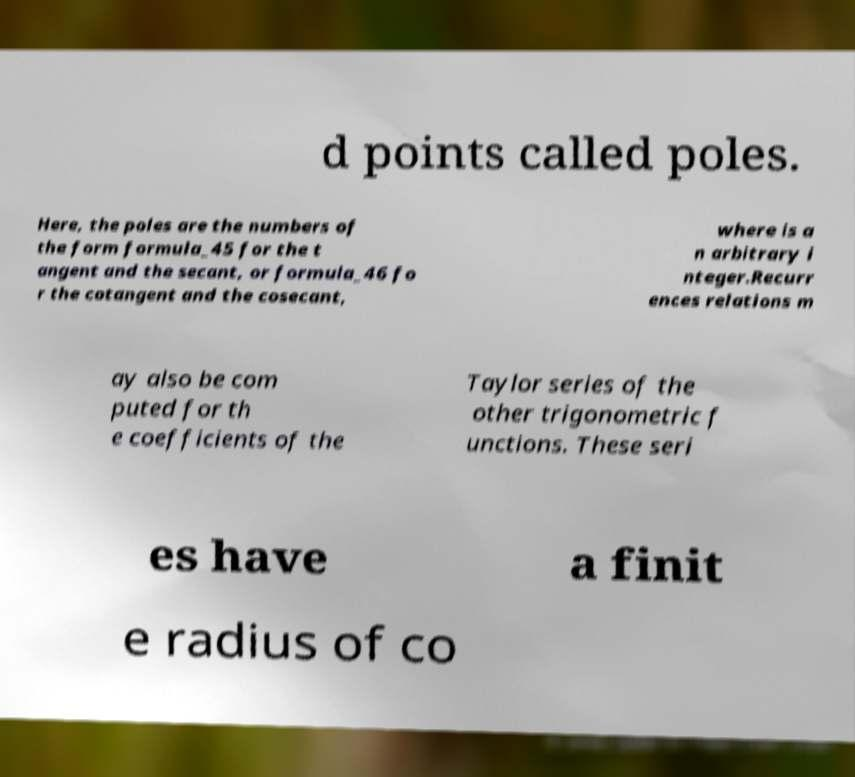There's text embedded in this image that I need extracted. Can you transcribe it verbatim? d points called poles. Here, the poles are the numbers of the form formula_45 for the t angent and the secant, or formula_46 fo r the cotangent and the cosecant, where is a n arbitrary i nteger.Recurr ences relations m ay also be com puted for th e coefficients of the Taylor series of the other trigonometric f unctions. These seri es have a finit e radius of co 